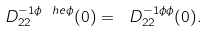Convert formula to latex. <formula><loc_0><loc_0><loc_500><loc_500>\ D _ { 2 2 } ^ { - 1 \phi \ h e \phi } ( 0 ) = \ D _ { 2 2 } ^ { - 1 \phi \phi } ( 0 ) .</formula> 